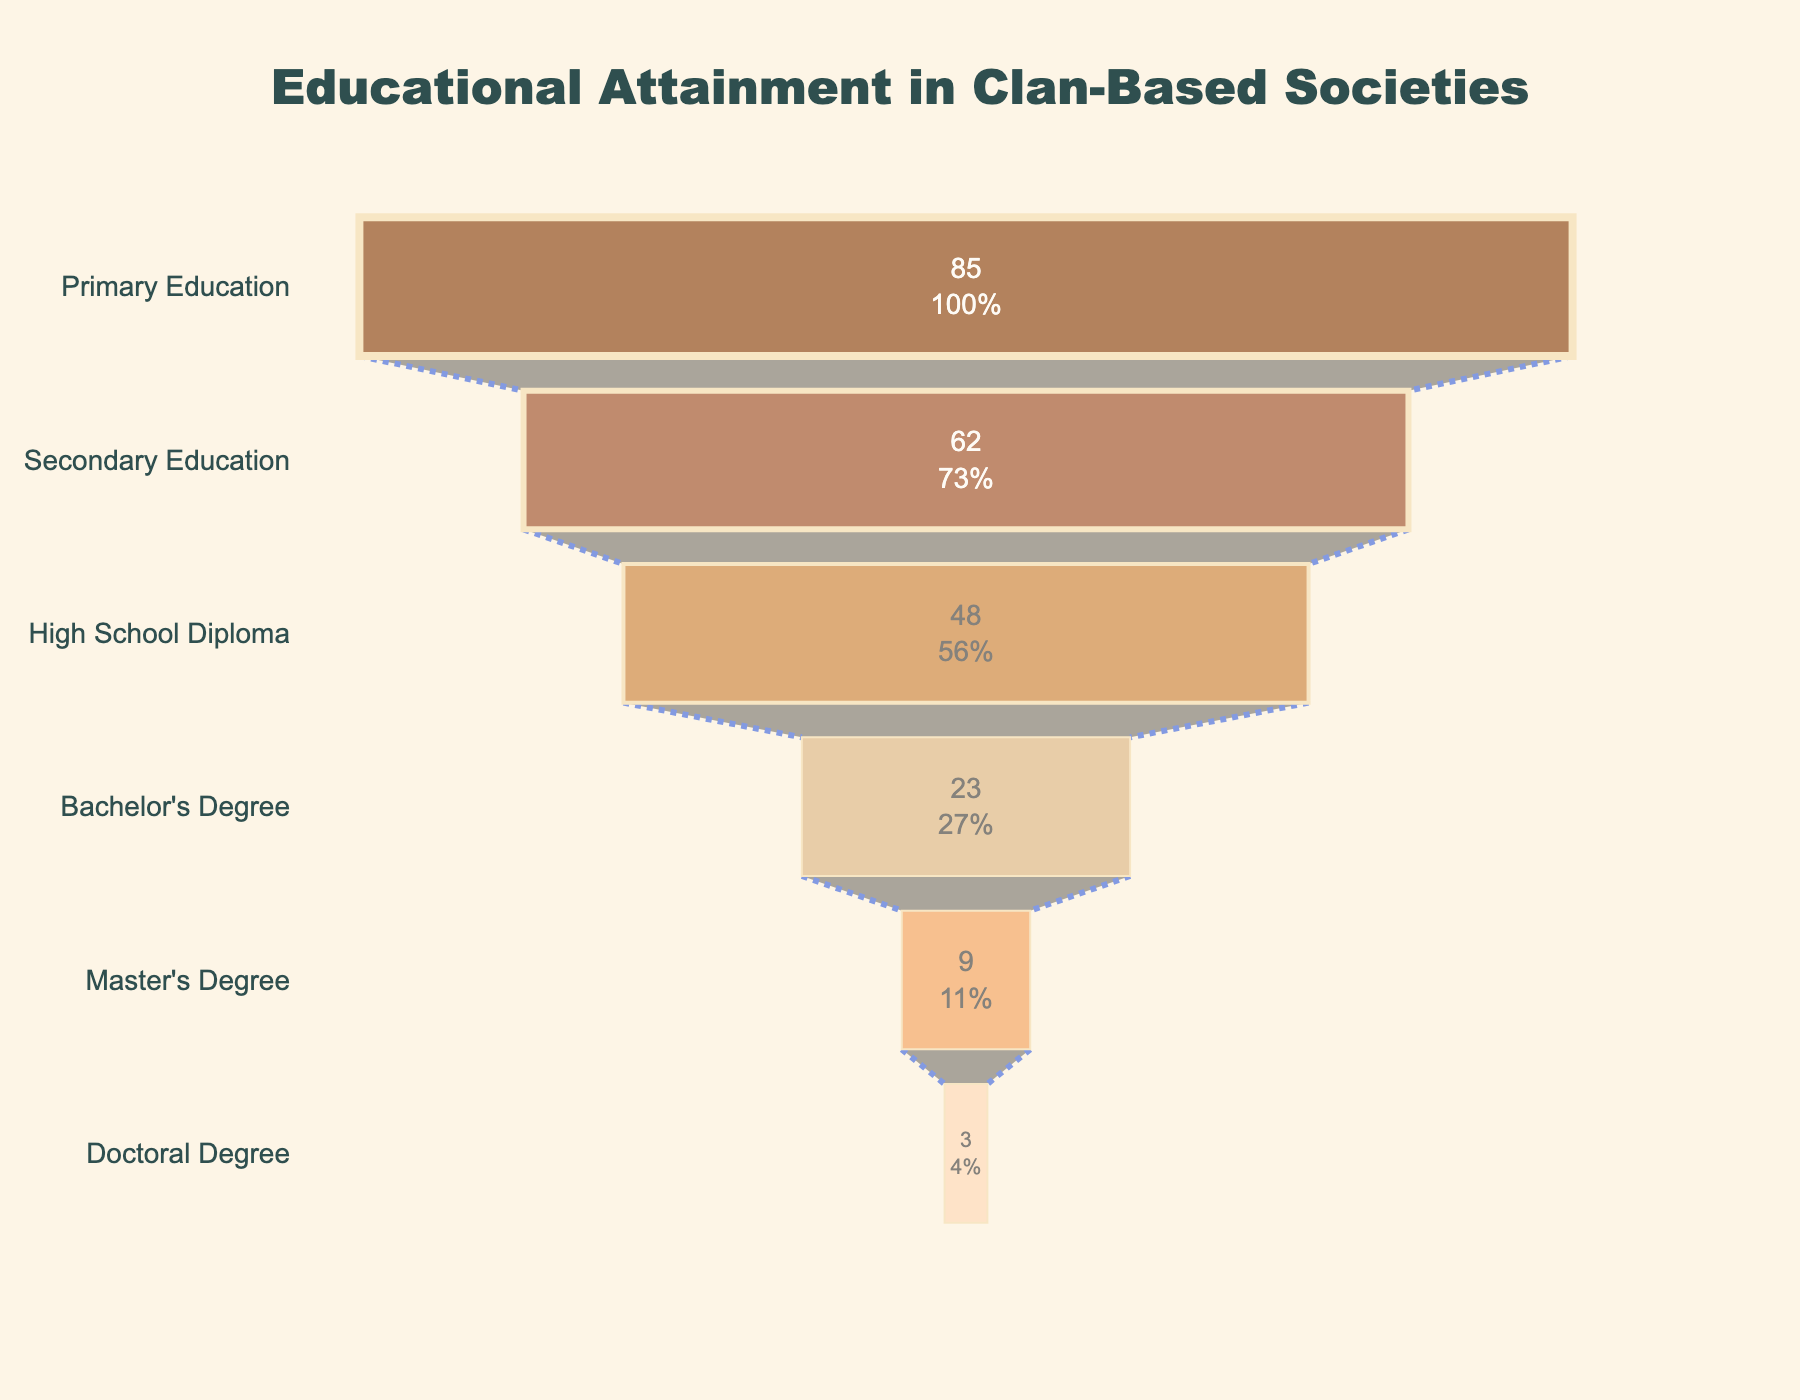How many education levels are shown in the figure? The figure displays six distinct education levels on the y-axis, each with a corresponding percentage.
Answer: Six What is the title of the figure? The title is prominently displayed at the top, centered and in a larger font. It reads "Educational Attainment in Clan-Based Societies."
Answer: Educational Attainment in Clan-Based Societies Which education level has the highest percentage? The figure shows the highest percentage at the top of the funnel chart. This level corresponds to Primary Education.
Answer: Primary Education How many more people attained a High School Diploma compared to a Bachelor's Degree? The percentage for a High School Diploma is 48% and for a Bachelor's Degree is 23%. Subtracting these values gives the difference: 48 - 23 = 25%.
Answer: 25% What's the percentage of people with a Master's Degree in the figure? The Master's Degree level is the second to the last in the funnel, with its percentage displayed inside the chart.
Answer: 9% Which education level has the lowest percentage? The lowest percentage is at the bottom of the funnel chart. This corresponds to the Doctoral Degree level.
Answer: Doctoral Degree What is the sum of percentages for Secondary Education and Bachelor's Degree? The figure shows 62% for Secondary Education and 23% for Bachelor's Degree. Adding these gives 62 + 23 = 85%.
Answer: 85% How does the percentage of people with a Master's Degree compare to those with a Doctoral Degree? The figure shows 9% for a Master's Degree and 3% for a Doctoral Degree. 9% is greater than 3%.
Answer: Master's Degree is greater If we were to remove those with Primary Education, what percentage of the population has at least a Secondary Education? Removing Primary Education means considering only the remaining levels. These percentages are 62%, 48%, 23%, 9%, and 3%. Since these percentages are presented in a cumulative manner in a funnel chart, the percentage of the population with at least a Secondary Education is 100% minus the Primary Education percentage: 100% - 85% = 15%.
Answer: 15% What can you infer about the trend of educational attainment from Primary Education to Doctoral Degree? The funnel chart shows a decreasing trend in percentages from Primary Education (85%) to Doctoral Degree (3%), indicating a gradual decline in the number of people achieving higher levels of education.
Answer: Decreasing trend 